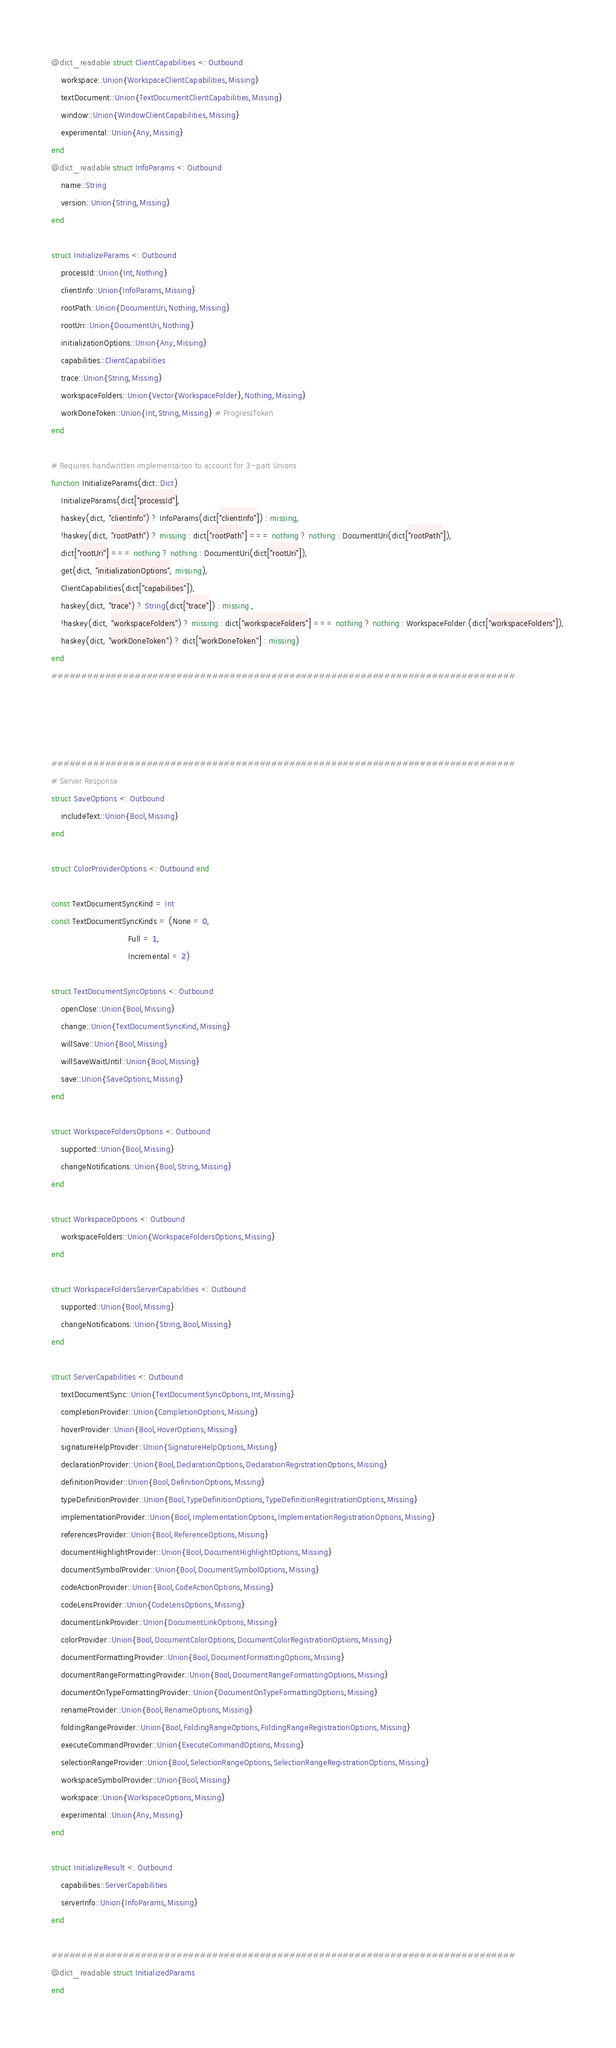<code> <loc_0><loc_0><loc_500><loc_500><_Julia_>@dict_readable struct ClientCapabilities <: Outbound
    workspace::Union{WorkspaceClientCapabilities,Missing}
    textDocument::Union{TextDocumentClientCapabilities,Missing}
    window::Union{WindowClientCapabilities,Missing}
    experimental::Union{Any,Missing}
end
@dict_readable struct InfoParams <: Outbound
    name::String
    version::Union{String,Missing}
end

struct InitializeParams <: Outbound
    processId::Union{Int,Nothing}
    clientInfo::Union{InfoParams,Missing}
    rootPath::Union{DocumentUri,Nothing,Missing}
    rootUri::Union{DocumentUri,Nothing}
    initializationOptions::Union{Any,Missing}
    capabilities::ClientCapabilities
    trace::Union{String,Missing}
    workspaceFolders::Union{Vector{WorkspaceFolder},Nothing,Missing}
    workDoneToken::Union{Int,String,Missing} # ProgressToken
end

# Requires handwritten implementaiton to account for 3-part Unions
function InitializeParams(dict::Dict)
    InitializeParams(dict["processId"],
    haskey(dict, "clientInfo") ? InfoParams(dict["clientInfo"]) : missing,
    !haskey(dict, "rootPath") ? missing : dict["rootPath"] === nothing ? nothing : DocumentUri(dict["rootPath"]),
    dict["rootUri"] === nothing ? nothing : DocumentUri(dict["rootUri"]),
    get(dict, "initializationOptions", missing),
    ClientCapabilities(dict["capabilities"]),
    haskey(dict, "trace") ? String(dict["trace"]) : missing ,
    !haskey(dict, "workspaceFolders") ? missing : dict["workspaceFolders"] === nothing ? nothing : WorkspaceFolder.(dict["workspaceFolders"]),
    haskey(dict, "workDoneToken") ? dict["workDoneToken"] : missing)
end
##############################################################################




##############################################################################
# Server Response
struct SaveOptions <: Outbound
    includeText::Union{Bool,Missing}
end

struct ColorProviderOptions <: Outbound end

const TextDocumentSyncKind = Int
const TextDocumentSyncKinds = (None = 0,
                               Full = 1,
                               Incremental = 2)

struct TextDocumentSyncOptions <: Outbound
    openClose::Union{Bool,Missing}
    change::Union{TextDocumentSyncKind,Missing}
    willSave::Union{Bool,Missing}
    willSaveWaitUntil::Union{Bool,Missing}
    save::Union{SaveOptions,Missing}
end

struct WorkspaceFoldersOptions <: Outbound
    supported::Union{Bool,Missing}
    changeNotifications::Union{Bool,String,Missing}
end

struct WorkspaceOptions <: Outbound
    workspaceFolders::Union{WorkspaceFoldersOptions,Missing}
end

struct WorkspaceFoldersServerCapabilities <: Outbound
    supported::Union{Bool,Missing}
    changeNotifications::Union{String,Bool,Missing}
end

struct ServerCapabilities <: Outbound
    textDocumentSync::Union{TextDocumentSyncOptions,Int,Missing}
    completionProvider::Union{CompletionOptions,Missing}
    hoverProvider::Union{Bool,HoverOptions,Missing}
    signatureHelpProvider::Union{SignatureHelpOptions,Missing}
    declarationProvider::Union{Bool,DeclarationOptions,DeclarationRegistrationOptions,Missing}
    definitionProvider::Union{Bool,DefinitionOptions,Missing}
    typeDefinitionProvider::Union{Bool,TypeDefinitionOptions,TypeDefinitionRegistrationOptions,Missing}
    implementationProvider::Union{Bool,ImplementationOptions,ImplementationRegistrationOptions,Missing}
    referencesProvider::Union{Bool,ReferenceOptions,Missing}
    documentHighlightProvider::Union{Bool,DocumentHighlightOptions,Missing}
    documentSymbolProvider::Union{Bool,DocumentSymbolOptions,Missing}
    codeActionProvider::Union{Bool,CodeActionOptions,Missing}
    codeLensProvider::Union{CodeLensOptions,Missing}
    documentLinkProvider::Union{DocumentLinkOptions,Missing}
    colorProvider::Union{Bool,DocumentColorOptions,DocumentColorRegistrationOptions,Missing}
    documentFormattingProvider::Union{Bool,DocumentFormattingOptions,Missing}
    documentRangeFormattingProvider::Union{Bool,DocumentRangeFormattingOptions,Missing}
    documentOnTypeFormattingProvider::Union{DocumentOnTypeFormattingOptions,Missing}
    renameProvider::Union{Bool,RenameOptions,Missing}
    foldingRangeProvider::Union{Bool,FoldingRangeOptions,FoldingRangeRegistrationOptions,Missing}
    executeCommandProvider::Union{ExecuteCommandOptions,Missing}
    selectionRangeProvider::Union{Bool,SelectionRangeOptions,SelectionRangeRegistrationOptions,Missing}
    workspaceSymbolProvider::Union{Bool,Missing}
    workspace::Union{WorkspaceOptions,Missing}
    experimental::Union{Any,Missing}
end

struct InitializeResult <: Outbound
    capabilities::ServerCapabilities
    serverInfo::Union{InfoParams,Missing}
end

##############################################################################
@dict_readable struct InitializedParams
end
</code> 